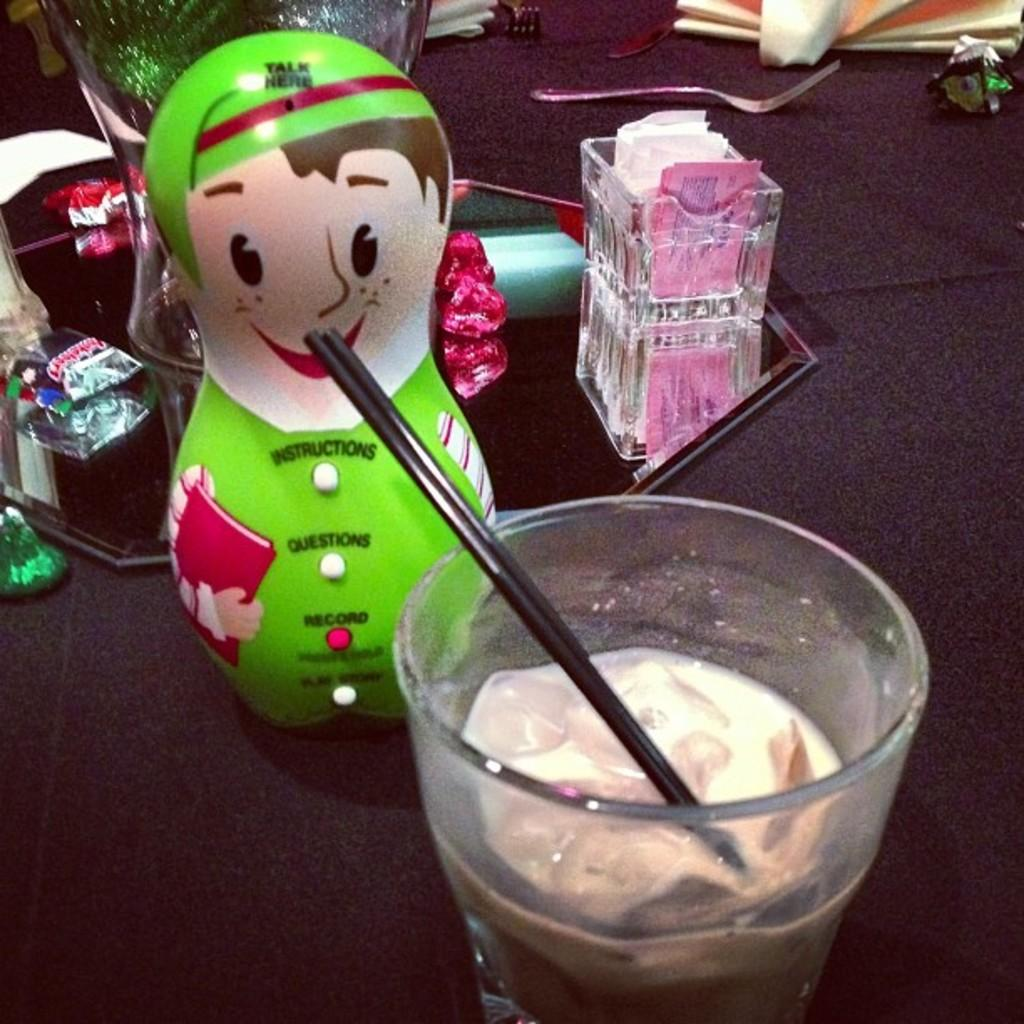What is located at the bottom of the image? There is a table at the bottom of the image. What is on the table in the image? There is a glass, toys, products, and a fork on the table. What might be used for drinking in the image? The glass on the table might be used for drinking. What else can be found on the table besides the glass? Toys, products, and a fork are also on the table. What type of ornament is hanging from the ceiling in the image? There is no ornament hanging from the ceiling in the image; the image only shows a table with various items on it. 